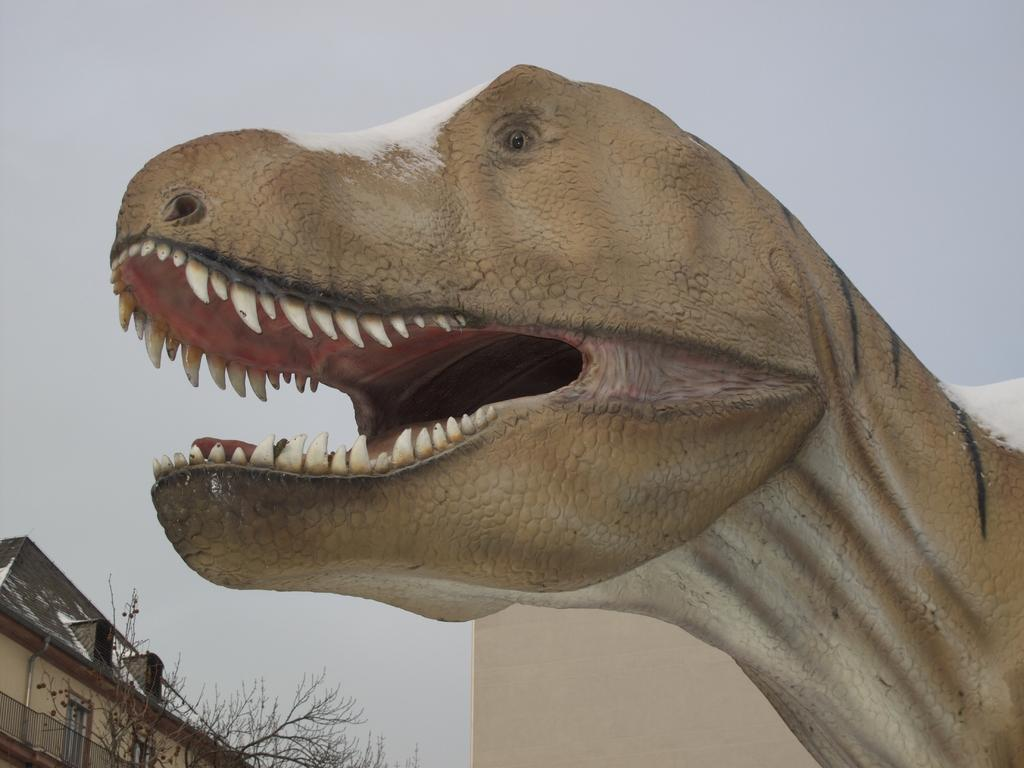What type of statue can be seen on the right side of the image? There is a statue of a dinosaur on the right side of the image. What type of building is visible in the image? There is a house in the image. What type of trees are present in the image? Deciduous trees are present in the image. Where are the trees located in the image? The trees are located on the bottom left side of the image. What is visible in the sky in the image? There are clouds in the sky. What riddle is the dinosaur statue trying to solve in the image? There is no indication in the image that the dinosaur statue is trying to solve a riddle. What color is the activity taking place in the image? There is no activity taking place in the image, so it is not possible to determine its color. 